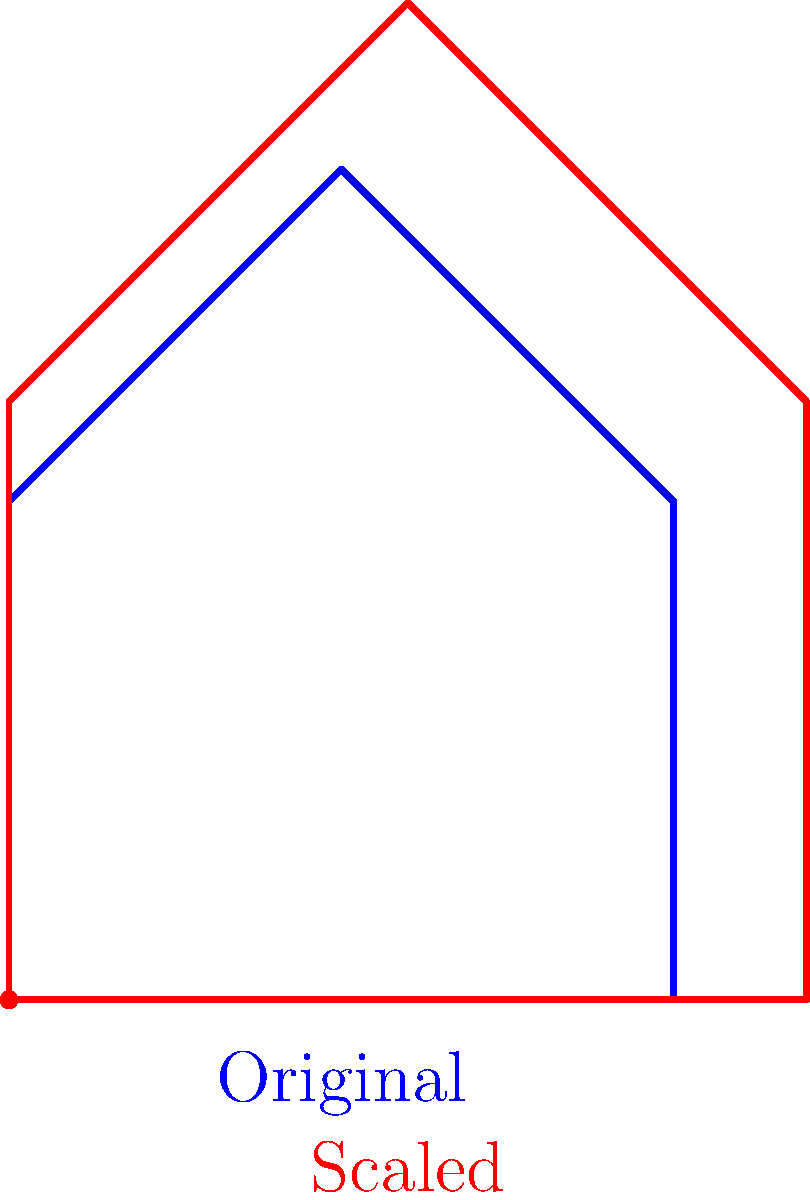A vintage bicycle manufacturer wants to scale up their classic frame design to accommodate taller riders. The original frame has a top tube length of 40 cm. If the entire frame needs to be scaled up by 20% to fit taller riders, what will be the new top tube length in centimeters? To solve this problem, we need to understand the concept of scaling in transformational geometry. When we scale an object, all its dimensions change by the same factor. Here's how we can approach this step-by-step:

1. Identify the original dimension:
   The original top tube length is 40 cm.

2. Understand the scaling factor:
   A 20% increase means multiplying by a factor of 1.2 (because 100% + 20% = 120% = 1.2).

3. Apply the scaling factor:
   New length = Original length × Scaling factor
   New length = 40 cm × 1.2

4. Calculate the result:
   New length = 48 cm

Therefore, after scaling the frame up by 20%, the new top tube length will be 48 cm.
Answer: 48 cm 